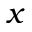Convert formula to latex. <formula><loc_0><loc_0><loc_500><loc_500>x</formula> 